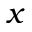Convert formula to latex. <formula><loc_0><loc_0><loc_500><loc_500>x</formula> 